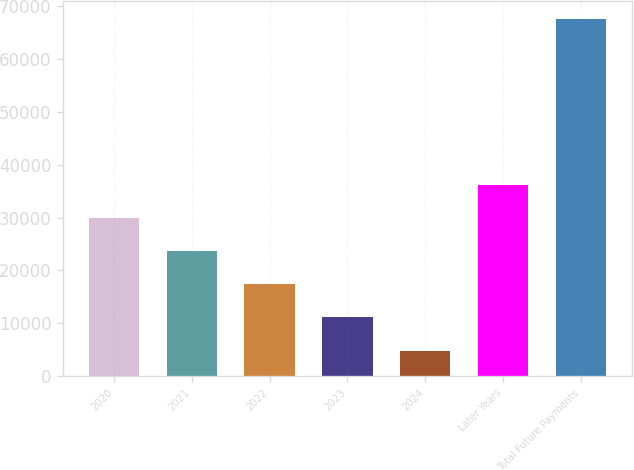Convert chart to OTSL. <chart><loc_0><loc_0><loc_500><loc_500><bar_chart><fcel>2020<fcel>2021<fcel>2022<fcel>2023<fcel>2024<fcel>Later Years<fcel>Total Future Payments<nl><fcel>29940<fcel>23665<fcel>17390<fcel>11115<fcel>4840<fcel>36215<fcel>67590<nl></chart> 